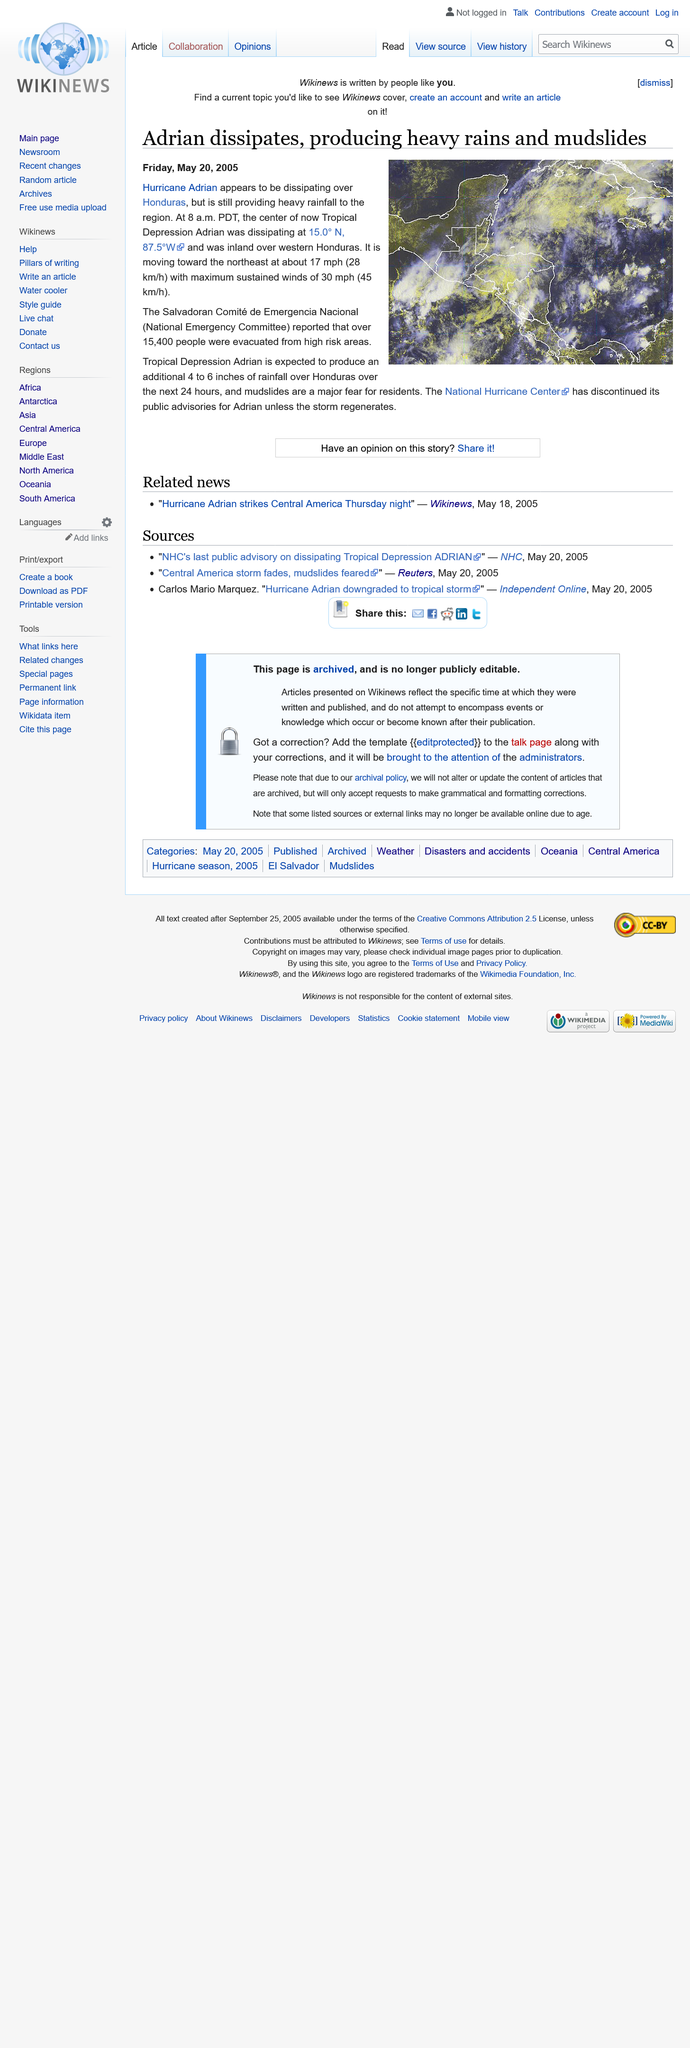Point out several critical features in this image. It is reported that 15,400 people were evacuated from high-risk areas. Honduras is the country where a hurricane appears to be dissipating. The Hurricane discussed in the article is named Adrian. 